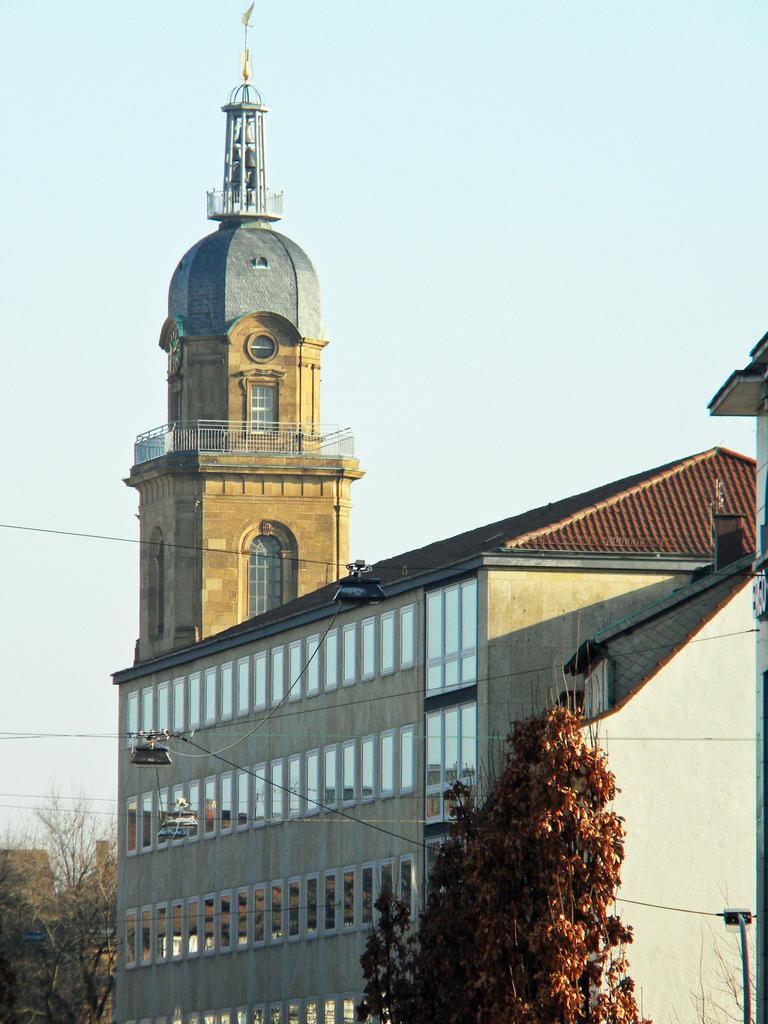Describe this image in one or two sentences. In the background we can see the sky. In this picture we can see a building, windows, trees and transmission wires. In the bottom right corner it seems like a light. At the top of a building we can see the bells. 